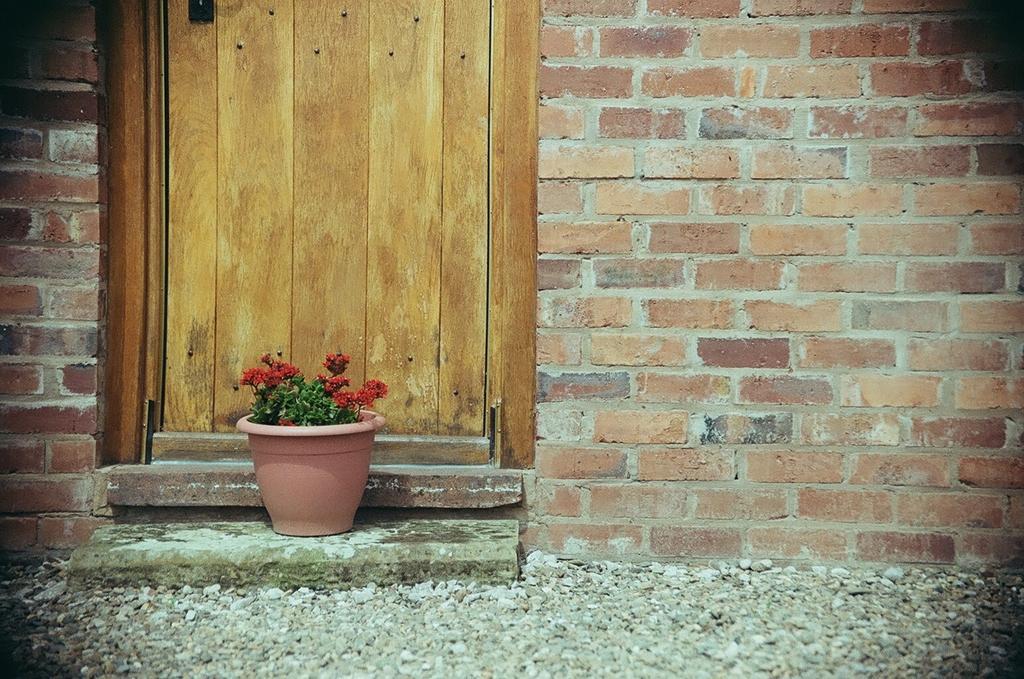Could you give a brief overview of what you see in this image? In this image, we can see the door, brick walls, flower plant with pot. At the bottom, we can see stones. Top of the image, we can see a black color object. 